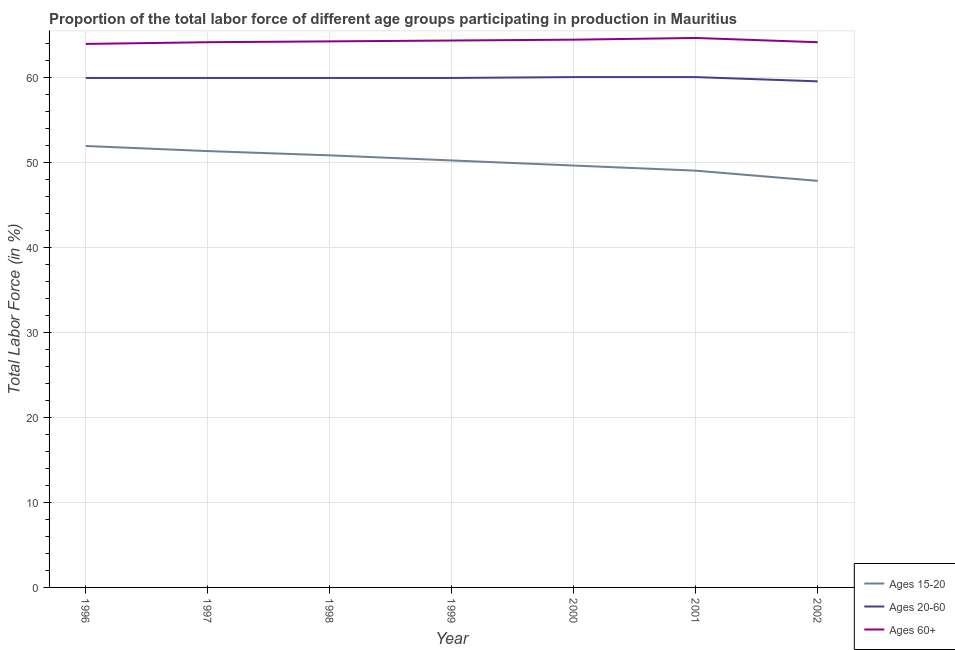How many different coloured lines are there?
Make the answer very short. 3. Is the number of lines equal to the number of legend labels?
Offer a terse response. Yes. What is the percentage of labor force within the age group 20-60 in 1997?
Make the answer very short. 59.9. Across all years, what is the maximum percentage of labor force within the age group 20-60?
Keep it short and to the point. 60. Across all years, what is the minimum percentage of labor force within the age group 20-60?
Keep it short and to the point. 59.5. In which year was the percentage of labor force above age 60 minimum?
Provide a short and direct response. 1996. What is the total percentage of labor force within the age group 20-60 in the graph?
Offer a very short reply. 419.1. What is the difference between the percentage of labor force within the age group 15-20 in 1999 and that in 2002?
Give a very brief answer. 2.4. What is the difference between the percentage of labor force above age 60 in 1998 and the percentage of labor force within the age group 15-20 in 2002?
Offer a terse response. 16.4. What is the average percentage of labor force above age 60 per year?
Your response must be concise. 64.23. In the year 2002, what is the difference between the percentage of labor force within the age group 15-20 and percentage of labor force within the age group 20-60?
Ensure brevity in your answer.  -11.7. In how many years, is the percentage of labor force within the age group 15-20 greater than 18 %?
Your response must be concise. 7. What is the ratio of the percentage of labor force within the age group 20-60 in 1998 to that in 2001?
Offer a terse response. 1. What is the difference between the highest and the second highest percentage of labor force within the age group 15-20?
Provide a short and direct response. 0.6. In how many years, is the percentage of labor force within the age group 20-60 greater than the average percentage of labor force within the age group 20-60 taken over all years?
Offer a terse response. 6. Is the sum of the percentage of labor force within the age group 20-60 in 1996 and 1997 greater than the maximum percentage of labor force within the age group 15-20 across all years?
Your answer should be very brief. Yes. Is the percentage of labor force within the age group 20-60 strictly less than the percentage of labor force within the age group 15-20 over the years?
Ensure brevity in your answer.  No. How many lines are there?
Your answer should be compact. 3. What is the difference between two consecutive major ticks on the Y-axis?
Your answer should be very brief. 10. Does the graph contain grids?
Offer a terse response. Yes. Where does the legend appear in the graph?
Provide a short and direct response. Bottom right. How are the legend labels stacked?
Ensure brevity in your answer.  Vertical. What is the title of the graph?
Your answer should be very brief. Proportion of the total labor force of different age groups participating in production in Mauritius. What is the label or title of the Y-axis?
Your answer should be compact. Total Labor Force (in %). What is the Total Labor Force (in %) of Ages 15-20 in 1996?
Your answer should be compact. 51.9. What is the Total Labor Force (in %) of Ages 20-60 in 1996?
Offer a terse response. 59.9. What is the Total Labor Force (in %) of Ages 60+ in 1996?
Offer a very short reply. 63.9. What is the Total Labor Force (in %) of Ages 15-20 in 1997?
Make the answer very short. 51.3. What is the Total Labor Force (in %) in Ages 20-60 in 1997?
Keep it short and to the point. 59.9. What is the Total Labor Force (in %) of Ages 60+ in 1997?
Make the answer very short. 64.1. What is the Total Labor Force (in %) of Ages 15-20 in 1998?
Ensure brevity in your answer.  50.8. What is the Total Labor Force (in %) of Ages 20-60 in 1998?
Your response must be concise. 59.9. What is the Total Labor Force (in %) of Ages 60+ in 1998?
Your answer should be very brief. 64.2. What is the Total Labor Force (in %) in Ages 15-20 in 1999?
Provide a succinct answer. 50.2. What is the Total Labor Force (in %) of Ages 20-60 in 1999?
Make the answer very short. 59.9. What is the Total Labor Force (in %) in Ages 60+ in 1999?
Provide a succinct answer. 64.3. What is the Total Labor Force (in %) of Ages 15-20 in 2000?
Make the answer very short. 49.6. What is the Total Labor Force (in %) of Ages 20-60 in 2000?
Offer a terse response. 60. What is the Total Labor Force (in %) of Ages 60+ in 2000?
Provide a succinct answer. 64.4. What is the Total Labor Force (in %) in Ages 20-60 in 2001?
Give a very brief answer. 60. What is the Total Labor Force (in %) in Ages 60+ in 2001?
Keep it short and to the point. 64.6. What is the Total Labor Force (in %) in Ages 15-20 in 2002?
Give a very brief answer. 47.8. What is the Total Labor Force (in %) in Ages 20-60 in 2002?
Your answer should be very brief. 59.5. What is the Total Labor Force (in %) of Ages 60+ in 2002?
Provide a short and direct response. 64.1. Across all years, what is the maximum Total Labor Force (in %) of Ages 15-20?
Your answer should be compact. 51.9. Across all years, what is the maximum Total Labor Force (in %) of Ages 20-60?
Ensure brevity in your answer.  60. Across all years, what is the maximum Total Labor Force (in %) of Ages 60+?
Your response must be concise. 64.6. Across all years, what is the minimum Total Labor Force (in %) of Ages 15-20?
Provide a short and direct response. 47.8. Across all years, what is the minimum Total Labor Force (in %) of Ages 20-60?
Provide a short and direct response. 59.5. Across all years, what is the minimum Total Labor Force (in %) of Ages 60+?
Give a very brief answer. 63.9. What is the total Total Labor Force (in %) of Ages 15-20 in the graph?
Offer a very short reply. 350.6. What is the total Total Labor Force (in %) in Ages 20-60 in the graph?
Offer a terse response. 419.1. What is the total Total Labor Force (in %) in Ages 60+ in the graph?
Your answer should be very brief. 449.6. What is the difference between the Total Labor Force (in %) in Ages 20-60 in 1996 and that in 1997?
Offer a very short reply. 0. What is the difference between the Total Labor Force (in %) of Ages 15-20 in 1996 and that in 1998?
Your answer should be very brief. 1.1. What is the difference between the Total Labor Force (in %) of Ages 60+ in 1996 and that in 1999?
Give a very brief answer. -0.4. What is the difference between the Total Labor Force (in %) of Ages 15-20 in 1996 and that in 2000?
Give a very brief answer. 2.3. What is the difference between the Total Labor Force (in %) of Ages 20-60 in 1996 and that in 2000?
Your answer should be compact. -0.1. What is the difference between the Total Labor Force (in %) of Ages 60+ in 1996 and that in 2000?
Make the answer very short. -0.5. What is the difference between the Total Labor Force (in %) of Ages 15-20 in 1996 and that in 2001?
Make the answer very short. 2.9. What is the difference between the Total Labor Force (in %) in Ages 60+ in 1996 and that in 2001?
Give a very brief answer. -0.7. What is the difference between the Total Labor Force (in %) in Ages 15-20 in 1997 and that in 1998?
Provide a succinct answer. 0.5. What is the difference between the Total Labor Force (in %) in Ages 60+ in 1997 and that in 1998?
Keep it short and to the point. -0.1. What is the difference between the Total Labor Force (in %) of Ages 20-60 in 1997 and that in 2000?
Your answer should be compact. -0.1. What is the difference between the Total Labor Force (in %) of Ages 60+ in 1997 and that in 2001?
Your answer should be compact. -0.5. What is the difference between the Total Labor Force (in %) of Ages 60+ in 1997 and that in 2002?
Your answer should be very brief. 0. What is the difference between the Total Labor Force (in %) of Ages 15-20 in 1998 and that in 1999?
Your answer should be compact. 0.6. What is the difference between the Total Labor Force (in %) of Ages 20-60 in 1998 and that in 1999?
Provide a short and direct response. 0. What is the difference between the Total Labor Force (in %) of Ages 15-20 in 1998 and that in 2000?
Give a very brief answer. 1.2. What is the difference between the Total Labor Force (in %) in Ages 15-20 in 1998 and that in 2001?
Give a very brief answer. 1.8. What is the difference between the Total Labor Force (in %) of Ages 20-60 in 1998 and that in 2001?
Offer a terse response. -0.1. What is the difference between the Total Labor Force (in %) of Ages 60+ in 1998 and that in 2001?
Your response must be concise. -0.4. What is the difference between the Total Labor Force (in %) of Ages 15-20 in 1998 and that in 2002?
Give a very brief answer. 3. What is the difference between the Total Labor Force (in %) of Ages 15-20 in 1999 and that in 2000?
Provide a succinct answer. 0.6. What is the difference between the Total Labor Force (in %) in Ages 20-60 in 1999 and that in 2000?
Ensure brevity in your answer.  -0.1. What is the difference between the Total Labor Force (in %) of Ages 60+ in 1999 and that in 2000?
Provide a succinct answer. -0.1. What is the difference between the Total Labor Force (in %) in Ages 15-20 in 1999 and that in 2001?
Your response must be concise. 1.2. What is the difference between the Total Labor Force (in %) in Ages 20-60 in 1999 and that in 2002?
Offer a terse response. 0.4. What is the difference between the Total Labor Force (in %) of Ages 15-20 in 2000 and that in 2002?
Provide a succinct answer. 1.8. What is the difference between the Total Labor Force (in %) of Ages 60+ in 2000 and that in 2002?
Keep it short and to the point. 0.3. What is the difference between the Total Labor Force (in %) of Ages 60+ in 2001 and that in 2002?
Ensure brevity in your answer.  0.5. What is the difference between the Total Labor Force (in %) of Ages 15-20 in 1996 and the Total Labor Force (in %) of Ages 20-60 in 1997?
Your answer should be compact. -8. What is the difference between the Total Labor Force (in %) in Ages 15-20 in 1996 and the Total Labor Force (in %) in Ages 20-60 in 1998?
Provide a succinct answer. -8. What is the difference between the Total Labor Force (in %) in Ages 15-20 in 1996 and the Total Labor Force (in %) in Ages 60+ in 1999?
Provide a short and direct response. -12.4. What is the difference between the Total Labor Force (in %) in Ages 20-60 in 1996 and the Total Labor Force (in %) in Ages 60+ in 2001?
Provide a succinct answer. -4.7. What is the difference between the Total Labor Force (in %) of Ages 15-20 in 1996 and the Total Labor Force (in %) of Ages 20-60 in 2002?
Offer a terse response. -7.6. What is the difference between the Total Labor Force (in %) of Ages 15-20 in 1997 and the Total Labor Force (in %) of Ages 60+ in 1998?
Offer a very short reply. -12.9. What is the difference between the Total Labor Force (in %) of Ages 20-60 in 1997 and the Total Labor Force (in %) of Ages 60+ in 1998?
Keep it short and to the point. -4.3. What is the difference between the Total Labor Force (in %) of Ages 15-20 in 1997 and the Total Labor Force (in %) of Ages 20-60 in 1999?
Your response must be concise. -8.6. What is the difference between the Total Labor Force (in %) of Ages 20-60 in 1997 and the Total Labor Force (in %) of Ages 60+ in 1999?
Ensure brevity in your answer.  -4.4. What is the difference between the Total Labor Force (in %) in Ages 20-60 in 1997 and the Total Labor Force (in %) in Ages 60+ in 2000?
Offer a terse response. -4.5. What is the difference between the Total Labor Force (in %) of Ages 15-20 in 1997 and the Total Labor Force (in %) of Ages 20-60 in 2001?
Your answer should be compact. -8.7. What is the difference between the Total Labor Force (in %) of Ages 15-20 in 1997 and the Total Labor Force (in %) of Ages 60+ in 2001?
Your answer should be compact. -13.3. What is the difference between the Total Labor Force (in %) in Ages 15-20 in 1997 and the Total Labor Force (in %) in Ages 60+ in 2002?
Provide a succinct answer. -12.8. What is the difference between the Total Labor Force (in %) in Ages 15-20 in 1998 and the Total Labor Force (in %) in Ages 20-60 in 1999?
Provide a succinct answer. -9.1. What is the difference between the Total Labor Force (in %) of Ages 15-20 in 1998 and the Total Labor Force (in %) of Ages 60+ in 1999?
Provide a succinct answer. -13.5. What is the difference between the Total Labor Force (in %) of Ages 20-60 in 1998 and the Total Labor Force (in %) of Ages 60+ in 1999?
Keep it short and to the point. -4.4. What is the difference between the Total Labor Force (in %) of Ages 15-20 in 1998 and the Total Labor Force (in %) of Ages 20-60 in 2000?
Provide a succinct answer. -9.2. What is the difference between the Total Labor Force (in %) of Ages 15-20 in 1998 and the Total Labor Force (in %) of Ages 60+ in 2000?
Make the answer very short. -13.6. What is the difference between the Total Labor Force (in %) in Ages 20-60 in 1998 and the Total Labor Force (in %) in Ages 60+ in 2000?
Offer a very short reply. -4.5. What is the difference between the Total Labor Force (in %) in Ages 15-20 in 1998 and the Total Labor Force (in %) in Ages 20-60 in 2001?
Your answer should be compact. -9.2. What is the difference between the Total Labor Force (in %) of Ages 15-20 in 1998 and the Total Labor Force (in %) of Ages 60+ in 2001?
Your response must be concise. -13.8. What is the difference between the Total Labor Force (in %) of Ages 20-60 in 1998 and the Total Labor Force (in %) of Ages 60+ in 2001?
Your answer should be compact. -4.7. What is the difference between the Total Labor Force (in %) in Ages 15-20 in 1999 and the Total Labor Force (in %) in Ages 20-60 in 2001?
Offer a terse response. -9.8. What is the difference between the Total Labor Force (in %) in Ages 15-20 in 1999 and the Total Labor Force (in %) in Ages 60+ in 2001?
Provide a succinct answer. -14.4. What is the difference between the Total Labor Force (in %) in Ages 20-60 in 1999 and the Total Labor Force (in %) in Ages 60+ in 2001?
Keep it short and to the point. -4.7. What is the difference between the Total Labor Force (in %) in Ages 15-20 in 1999 and the Total Labor Force (in %) in Ages 20-60 in 2002?
Provide a succinct answer. -9.3. What is the difference between the Total Labor Force (in %) of Ages 20-60 in 1999 and the Total Labor Force (in %) of Ages 60+ in 2002?
Provide a succinct answer. -4.2. What is the difference between the Total Labor Force (in %) in Ages 15-20 in 2000 and the Total Labor Force (in %) in Ages 60+ in 2001?
Give a very brief answer. -15. What is the difference between the Total Labor Force (in %) in Ages 15-20 in 2000 and the Total Labor Force (in %) in Ages 20-60 in 2002?
Keep it short and to the point. -9.9. What is the difference between the Total Labor Force (in %) of Ages 15-20 in 2001 and the Total Labor Force (in %) of Ages 20-60 in 2002?
Your answer should be compact. -10.5. What is the difference between the Total Labor Force (in %) in Ages 15-20 in 2001 and the Total Labor Force (in %) in Ages 60+ in 2002?
Ensure brevity in your answer.  -15.1. What is the average Total Labor Force (in %) of Ages 15-20 per year?
Your answer should be compact. 50.09. What is the average Total Labor Force (in %) of Ages 20-60 per year?
Provide a short and direct response. 59.87. What is the average Total Labor Force (in %) in Ages 60+ per year?
Keep it short and to the point. 64.23. In the year 1996, what is the difference between the Total Labor Force (in %) of Ages 15-20 and Total Labor Force (in %) of Ages 20-60?
Ensure brevity in your answer.  -8. In the year 1996, what is the difference between the Total Labor Force (in %) in Ages 20-60 and Total Labor Force (in %) in Ages 60+?
Keep it short and to the point. -4. In the year 1997, what is the difference between the Total Labor Force (in %) of Ages 15-20 and Total Labor Force (in %) of Ages 20-60?
Offer a terse response. -8.6. In the year 1998, what is the difference between the Total Labor Force (in %) in Ages 20-60 and Total Labor Force (in %) in Ages 60+?
Your response must be concise. -4.3. In the year 1999, what is the difference between the Total Labor Force (in %) of Ages 15-20 and Total Labor Force (in %) of Ages 20-60?
Ensure brevity in your answer.  -9.7. In the year 1999, what is the difference between the Total Labor Force (in %) in Ages 15-20 and Total Labor Force (in %) in Ages 60+?
Your answer should be compact. -14.1. In the year 1999, what is the difference between the Total Labor Force (in %) in Ages 20-60 and Total Labor Force (in %) in Ages 60+?
Your answer should be compact. -4.4. In the year 2000, what is the difference between the Total Labor Force (in %) of Ages 15-20 and Total Labor Force (in %) of Ages 60+?
Give a very brief answer. -14.8. In the year 2001, what is the difference between the Total Labor Force (in %) of Ages 15-20 and Total Labor Force (in %) of Ages 20-60?
Ensure brevity in your answer.  -11. In the year 2001, what is the difference between the Total Labor Force (in %) in Ages 15-20 and Total Labor Force (in %) in Ages 60+?
Offer a very short reply. -15.6. In the year 2001, what is the difference between the Total Labor Force (in %) of Ages 20-60 and Total Labor Force (in %) of Ages 60+?
Your answer should be compact. -4.6. In the year 2002, what is the difference between the Total Labor Force (in %) of Ages 15-20 and Total Labor Force (in %) of Ages 20-60?
Make the answer very short. -11.7. In the year 2002, what is the difference between the Total Labor Force (in %) in Ages 15-20 and Total Labor Force (in %) in Ages 60+?
Offer a very short reply. -16.3. In the year 2002, what is the difference between the Total Labor Force (in %) of Ages 20-60 and Total Labor Force (in %) of Ages 60+?
Provide a short and direct response. -4.6. What is the ratio of the Total Labor Force (in %) in Ages 15-20 in 1996 to that in 1997?
Provide a short and direct response. 1.01. What is the ratio of the Total Labor Force (in %) of Ages 15-20 in 1996 to that in 1998?
Offer a terse response. 1.02. What is the ratio of the Total Labor Force (in %) of Ages 15-20 in 1996 to that in 1999?
Ensure brevity in your answer.  1.03. What is the ratio of the Total Labor Force (in %) of Ages 60+ in 1996 to that in 1999?
Offer a very short reply. 0.99. What is the ratio of the Total Labor Force (in %) in Ages 15-20 in 1996 to that in 2000?
Your response must be concise. 1.05. What is the ratio of the Total Labor Force (in %) of Ages 15-20 in 1996 to that in 2001?
Your answer should be compact. 1.06. What is the ratio of the Total Labor Force (in %) in Ages 60+ in 1996 to that in 2001?
Give a very brief answer. 0.99. What is the ratio of the Total Labor Force (in %) in Ages 15-20 in 1996 to that in 2002?
Your answer should be very brief. 1.09. What is the ratio of the Total Labor Force (in %) of Ages 60+ in 1996 to that in 2002?
Your answer should be very brief. 1. What is the ratio of the Total Labor Force (in %) in Ages 15-20 in 1997 to that in 1998?
Keep it short and to the point. 1.01. What is the ratio of the Total Labor Force (in %) of Ages 20-60 in 1997 to that in 1998?
Provide a short and direct response. 1. What is the ratio of the Total Labor Force (in %) in Ages 60+ in 1997 to that in 1998?
Offer a very short reply. 1. What is the ratio of the Total Labor Force (in %) in Ages 15-20 in 1997 to that in 1999?
Your answer should be compact. 1.02. What is the ratio of the Total Labor Force (in %) of Ages 20-60 in 1997 to that in 1999?
Make the answer very short. 1. What is the ratio of the Total Labor Force (in %) in Ages 60+ in 1997 to that in 1999?
Ensure brevity in your answer.  1. What is the ratio of the Total Labor Force (in %) in Ages 15-20 in 1997 to that in 2000?
Your answer should be very brief. 1.03. What is the ratio of the Total Labor Force (in %) in Ages 60+ in 1997 to that in 2000?
Ensure brevity in your answer.  1. What is the ratio of the Total Labor Force (in %) in Ages 15-20 in 1997 to that in 2001?
Give a very brief answer. 1.05. What is the ratio of the Total Labor Force (in %) in Ages 15-20 in 1997 to that in 2002?
Your response must be concise. 1.07. What is the ratio of the Total Labor Force (in %) of Ages 20-60 in 1997 to that in 2002?
Give a very brief answer. 1.01. What is the ratio of the Total Labor Force (in %) in Ages 60+ in 1997 to that in 2002?
Keep it short and to the point. 1. What is the ratio of the Total Labor Force (in %) in Ages 15-20 in 1998 to that in 1999?
Keep it short and to the point. 1.01. What is the ratio of the Total Labor Force (in %) in Ages 20-60 in 1998 to that in 1999?
Offer a very short reply. 1. What is the ratio of the Total Labor Force (in %) in Ages 15-20 in 1998 to that in 2000?
Keep it short and to the point. 1.02. What is the ratio of the Total Labor Force (in %) of Ages 20-60 in 1998 to that in 2000?
Offer a very short reply. 1. What is the ratio of the Total Labor Force (in %) of Ages 60+ in 1998 to that in 2000?
Provide a short and direct response. 1. What is the ratio of the Total Labor Force (in %) in Ages 15-20 in 1998 to that in 2001?
Offer a terse response. 1.04. What is the ratio of the Total Labor Force (in %) in Ages 60+ in 1998 to that in 2001?
Ensure brevity in your answer.  0.99. What is the ratio of the Total Labor Force (in %) in Ages 15-20 in 1998 to that in 2002?
Your answer should be compact. 1.06. What is the ratio of the Total Labor Force (in %) of Ages 20-60 in 1998 to that in 2002?
Your answer should be very brief. 1.01. What is the ratio of the Total Labor Force (in %) in Ages 60+ in 1998 to that in 2002?
Provide a succinct answer. 1. What is the ratio of the Total Labor Force (in %) of Ages 15-20 in 1999 to that in 2000?
Make the answer very short. 1.01. What is the ratio of the Total Labor Force (in %) of Ages 15-20 in 1999 to that in 2001?
Make the answer very short. 1.02. What is the ratio of the Total Labor Force (in %) of Ages 15-20 in 1999 to that in 2002?
Your response must be concise. 1.05. What is the ratio of the Total Labor Force (in %) of Ages 20-60 in 1999 to that in 2002?
Offer a terse response. 1.01. What is the ratio of the Total Labor Force (in %) of Ages 15-20 in 2000 to that in 2001?
Offer a very short reply. 1.01. What is the ratio of the Total Labor Force (in %) in Ages 20-60 in 2000 to that in 2001?
Offer a very short reply. 1. What is the ratio of the Total Labor Force (in %) of Ages 15-20 in 2000 to that in 2002?
Give a very brief answer. 1.04. What is the ratio of the Total Labor Force (in %) of Ages 20-60 in 2000 to that in 2002?
Your answer should be compact. 1.01. What is the ratio of the Total Labor Force (in %) of Ages 15-20 in 2001 to that in 2002?
Your response must be concise. 1.03. What is the ratio of the Total Labor Force (in %) in Ages 20-60 in 2001 to that in 2002?
Your answer should be very brief. 1.01. What is the ratio of the Total Labor Force (in %) of Ages 60+ in 2001 to that in 2002?
Provide a short and direct response. 1.01. What is the difference between the highest and the second highest Total Labor Force (in %) in Ages 60+?
Your answer should be compact. 0.2. What is the difference between the highest and the lowest Total Labor Force (in %) of Ages 15-20?
Provide a succinct answer. 4.1. What is the difference between the highest and the lowest Total Labor Force (in %) in Ages 20-60?
Provide a short and direct response. 0.5. 